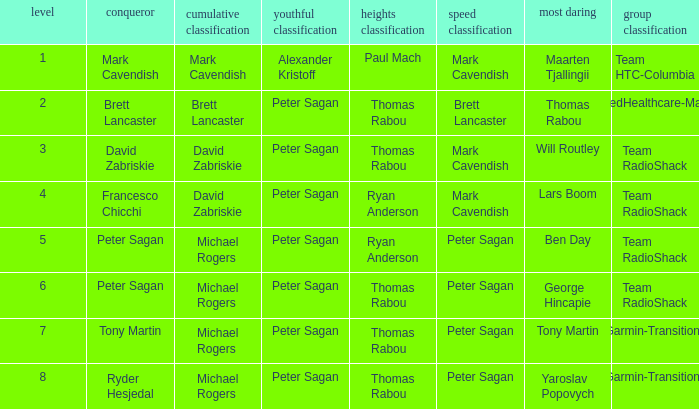When Mark Cavendish wins sprint classification and Maarten Tjallingii wins most courageous, who wins youth classification? Alexander Kristoff. 